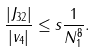Convert formula to latex. <formula><loc_0><loc_0><loc_500><loc_500>\frac { | J _ { 3 2 } | } { | v _ { 4 } | } \leq s \frac { 1 } { N _ { 1 } ^ { 8 } } .</formula> 